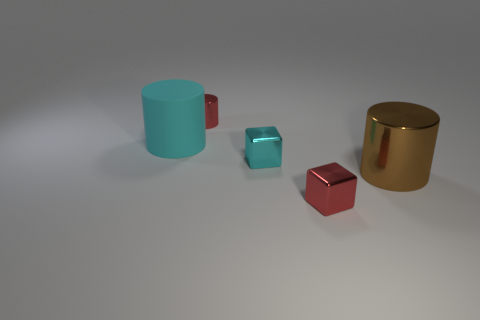Subtract all brown cylinders. How many cylinders are left? 2 Subtract all cyan cubes. How many cubes are left? 1 Subtract all cylinders. How many objects are left? 2 Subtract 1 blocks. How many blocks are left? 1 Add 5 cyan metal blocks. How many objects exist? 10 Subtract 1 red blocks. How many objects are left? 4 Subtract all gray blocks. Subtract all cyan cylinders. How many blocks are left? 2 Subtract all cyan cylinders. How many purple blocks are left? 0 Subtract all tiny metallic cylinders. Subtract all small red cylinders. How many objects are left? 3 Add 3 small cylinders. How many small cylinders are left? 4 